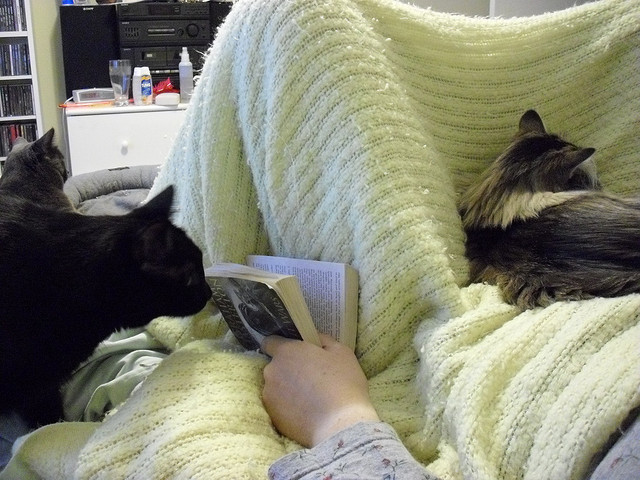How many cats are there? 3 